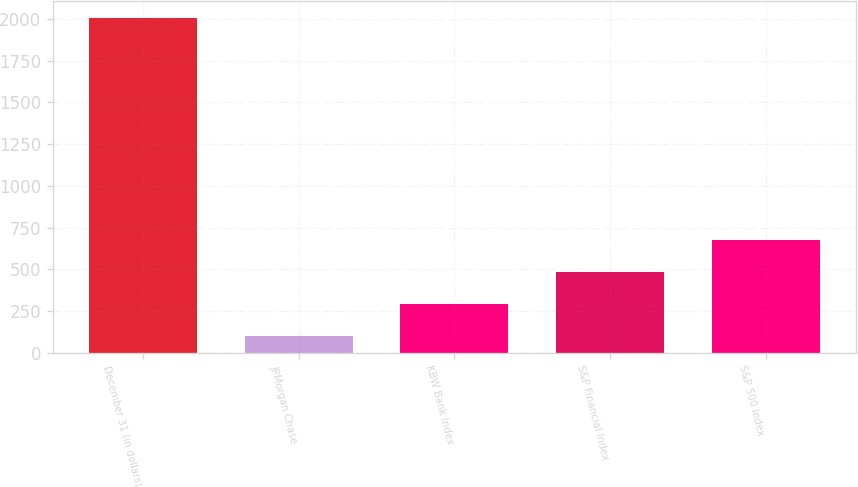<chart> <loc_0><loc_0><loc_500><loc_500><bar_chart><fcel>December 31 (in dollars)<fcel>JPMorgan Chase<fcel>KBW Bank Index<fcel>S&P Financial Index<fcel>S&P 500 Index<nl><fcel>2009<fcel>100<fcel>290.9<fcel>481.8<fcel>672.7<nl></chart> 